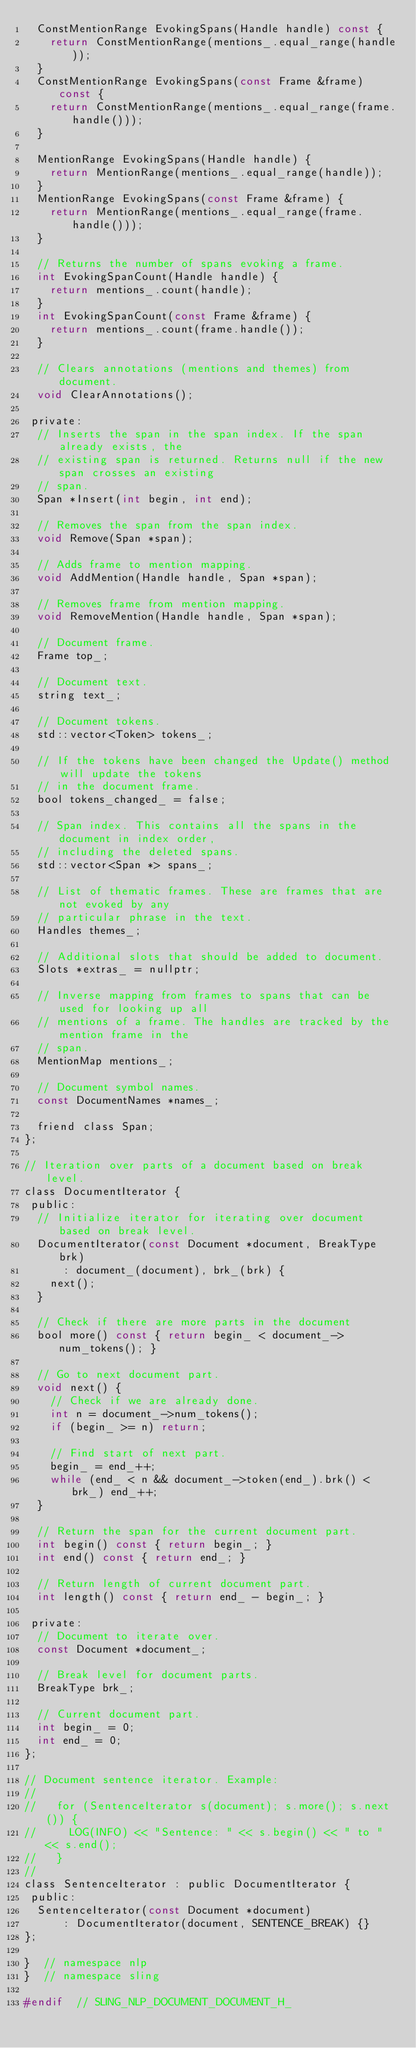<code> <loc_0><loc_0><loc_500><loc_500><_C_>  ConstMentionRange EvokingSpans(Handle handle) const {
    return ConstMentionRange(mentions_.equal_range(handle));
  }
  ConstMentionRange EvokingSpans(const Frame &frame) const {
    return ConstMentionRange(mentions_.equal_range(frame.handle()));
  }

  MentionRange EvokingSpans(Handle handle) {
    return MentionRange(mentions_.equal_range(handle));
  }
  MentionRange EvokingSpans(const Frame &frame) {
    return MentionRange(mentions_.equal_range(frame.handle()));
  }

  // Returns the number of spans evoking a frame.
  int EvokingSpanCount(Handle handle) {
    return mentions_.count(handle);
  }
  int EvokingSpanCount(const Frame &frame) {
    return mentions_.count(frame.handle());
  }

  // Clears annotations (mentions and themes) from document.
  void ClearAnnotations();

 private:
  // Inserts the span in the span index. If the span already exists, the
  // existing span is returned. Returns null if the new span crosses an existing
  // span.
  Span *Insert(int begin, int end);

  // Removes the span from the span index.
  void Remove(Span *span);

  // Adds frame to mention mapping.
  void AddMention(Handle handle, Span *span);

  // Removes frame from mention mapping.
  void RemoveMention(Handle handle, Span *span);

  // Document frame.
  Frame top_;

  // Document text.
  string text_;

  // Document tokens.
  std::vector<Token> tokens_;

  // If the tokens have been changed the Update() method will update the tokens
  // in the document frame.
  bool tokens_changed_ = false;

  // Span index. This contains all the spans in the document in index order,
  // including the deleted spans.
  std::vector<Span *> spans_;

  // List of thematic frames. These are frames that are not evoked by any
  // particular phrase in the text.
  Handles themes_;

  // Additional slots that should be added to document.
  Slots *extras_ = nullptr;

  // Inverse mapping from frames to spans that can be used for looking up all
  // mentions of a frame. The handles are tracked by the mention frame in the
  // span.
  MentionMap mentions_;

  // Document symbol names.
  const DocumentNames *names_;

  friend class Span;
};

// Iteration over parts of a document based on break level.
class DocumentIterator {
 public:
  // Initialize iterator for iterating over document based on break level.
  DocumentIterator(const Document *document, BreakType brk)
      : document_(document), brk_(brk) {
    next();
  }

  // Check if there are more parts in the document
  bool more() const { return begin_ < document_->num_tokens(); }

  // Go to next document part.
  void next() {
    // Check if we are already done.
    int n = document_->num_tokens();
    if (begin_ >= n) return;

    // Find start of next part.
    begin_ = end_++;
    while (end_ < n && document_->token(end_).brk() < brk_) end_++;
  }

  // Return the span for the current document part.
  int begin() const { return begin_; }
  int end() const { return end_; }

  // Return length of current document part.
  int length() const { return end_ - begin_; }

 private:
  // Document to iterate over.
  const Document *document_;

  // Break level for document parts.
  BreakType brk_;

  // Current document part.
  int begin_ = 0;
  int end_ = 0;
};

// Document sentence iterator. Example:
//
//   for (SentenceIterator s(document); s.more(); s.next()) {
//     LOG(INFO) << "Sentence: " << s.begin() << " to " << s.end();
//   }
//
class SentenceIterator : public DocumentIterator {
 public:
  SentenceIterator(const Document *document)
      : DocumentIterator(document, SENTENCE_BREAK) {}
};

}  // namespace nlp
}  // namespace sling

#endif  // SLING_NLP_DOCUMENT_DOCUMENT_H_

</code> 